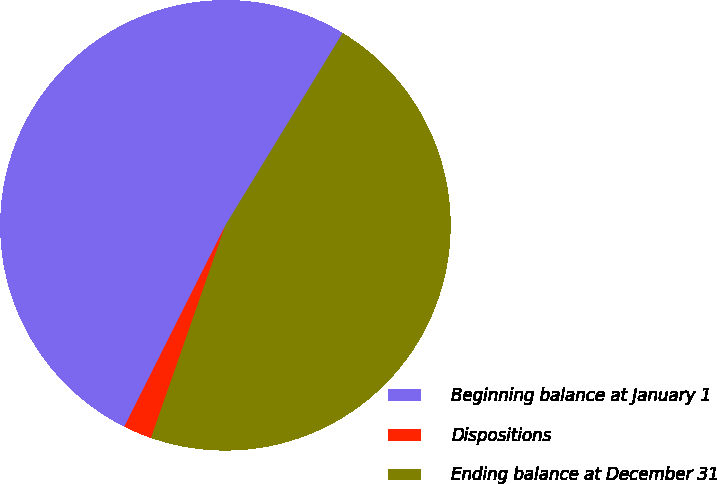<chart> <loc_0><loc_0><loc_500><loc_500><pie_chart><fcel>Beginning balance at January 1<fcel>Dispositions<fcel>Ending balance at December 31<nl><fcel>51.31%<fcel>2.05%<fcel>46.64%<nl></chart> 